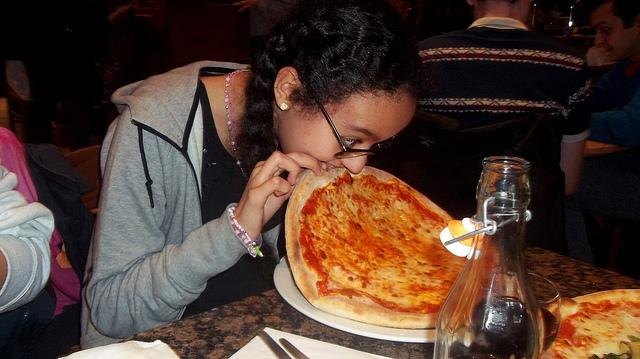What would most people do first before biting their pizza?

Choices:
A) slice it
B) ice it
C) dress it
D) cool it slice it 